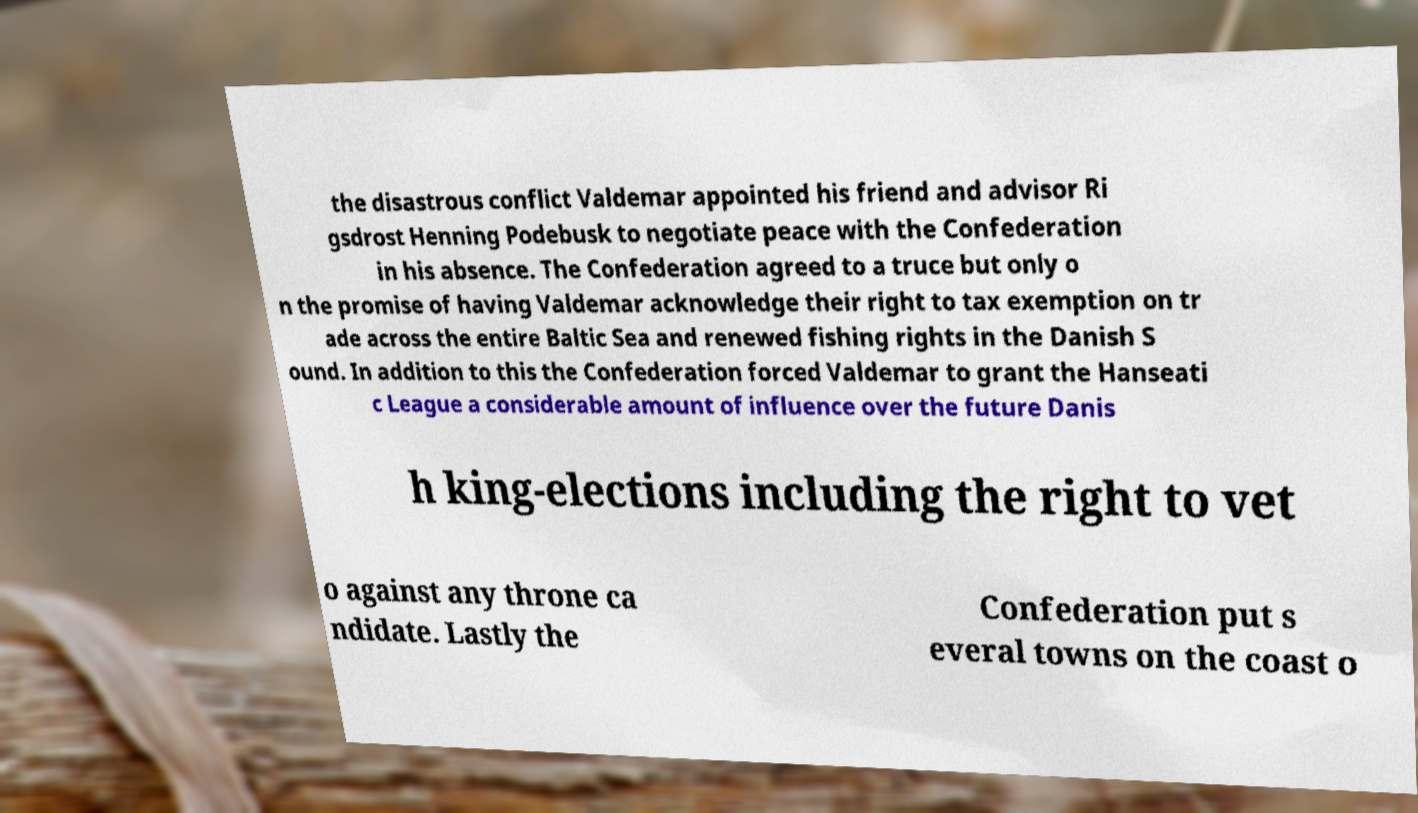Please read and relay the text visible in this image. What does it say? the disastrous conflict Valdemar appointed his friend and advisor Ri gsdrost Henning Podebusk to negotiate peace with the Confederation in his absence. The Confederation agreed to a truce but only o n the promise of having Valdemar acknowledge their right to tax exemption on tr ade across the entire Baltic Sea and renewed fishing rights in the Danish S ound. In addition to this the Confederation forced Valdemar to grant the Hanseati c League a considerable amount of influence over the future Danis h king-elections including the right to vet o against any throne ca ndidate. Lastly the Confederation put s everal towns on the coast o 